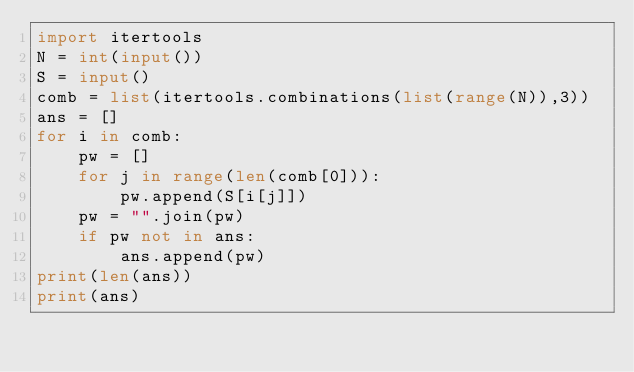<code> <loc_0><loc_0><loc_500><loc_500><_Python_>import itertools
N = int(input())
S = input()
comb = list(itertools.combinations(list(range(N)),3))
ans = []
for i in comb:
    pw = []
    for j in range(len(comb[0])):
        pw.append(S[i[j]])
    pw = "".join(pw)
    if pw not in ans:
        ans.append(pw)
print(len(ans))
print(ans)</code> 